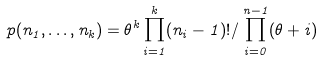Convert formula to latex. <formula><loc_0><loc_0><loc_500><loc_500>p ( n _ { 1 } , \dots , n _ { k } ) = \theta ^ { k } \prod _ { i = 1 } ^ { k } ( n _ { i } - 1 ) ! / \prod _ { i = 0 } ^ { n - 1 } ( \theta + i )</formula> 